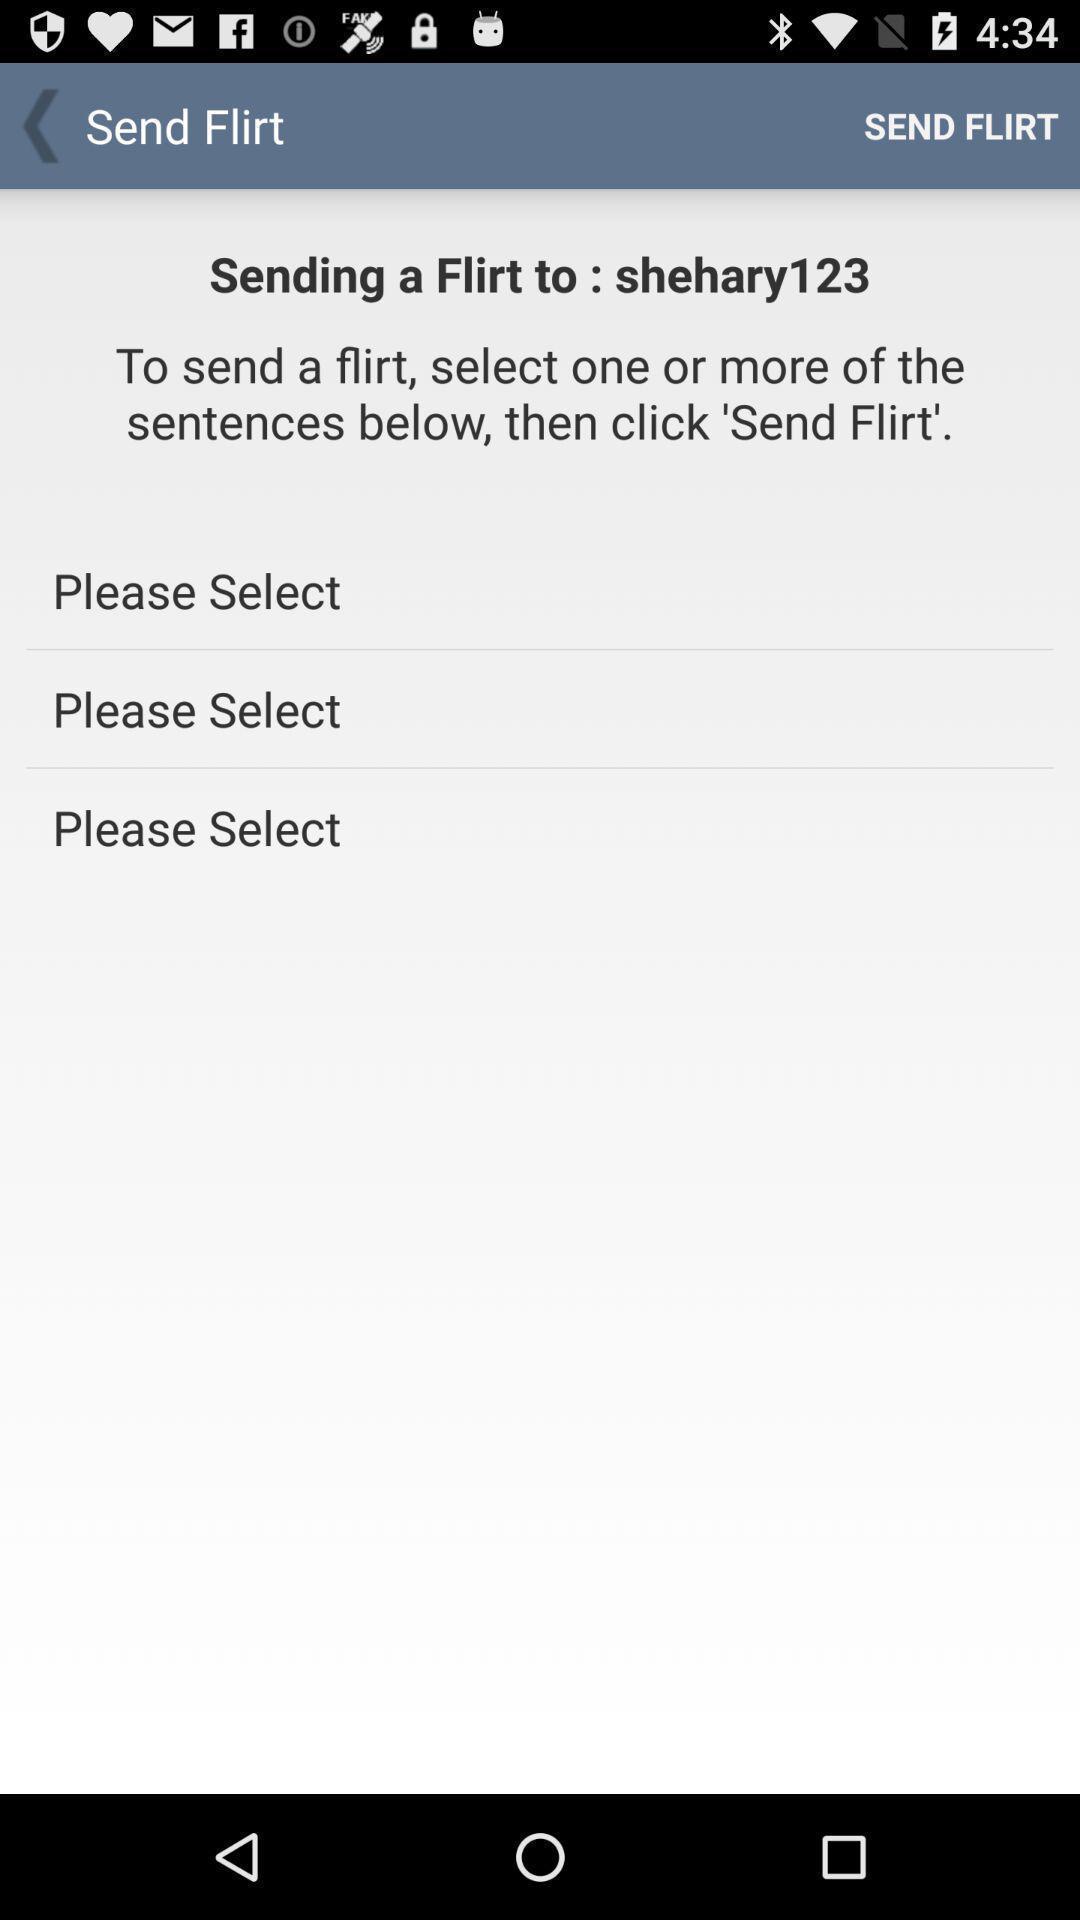What details can you identify in this image? Page of a social media app. 